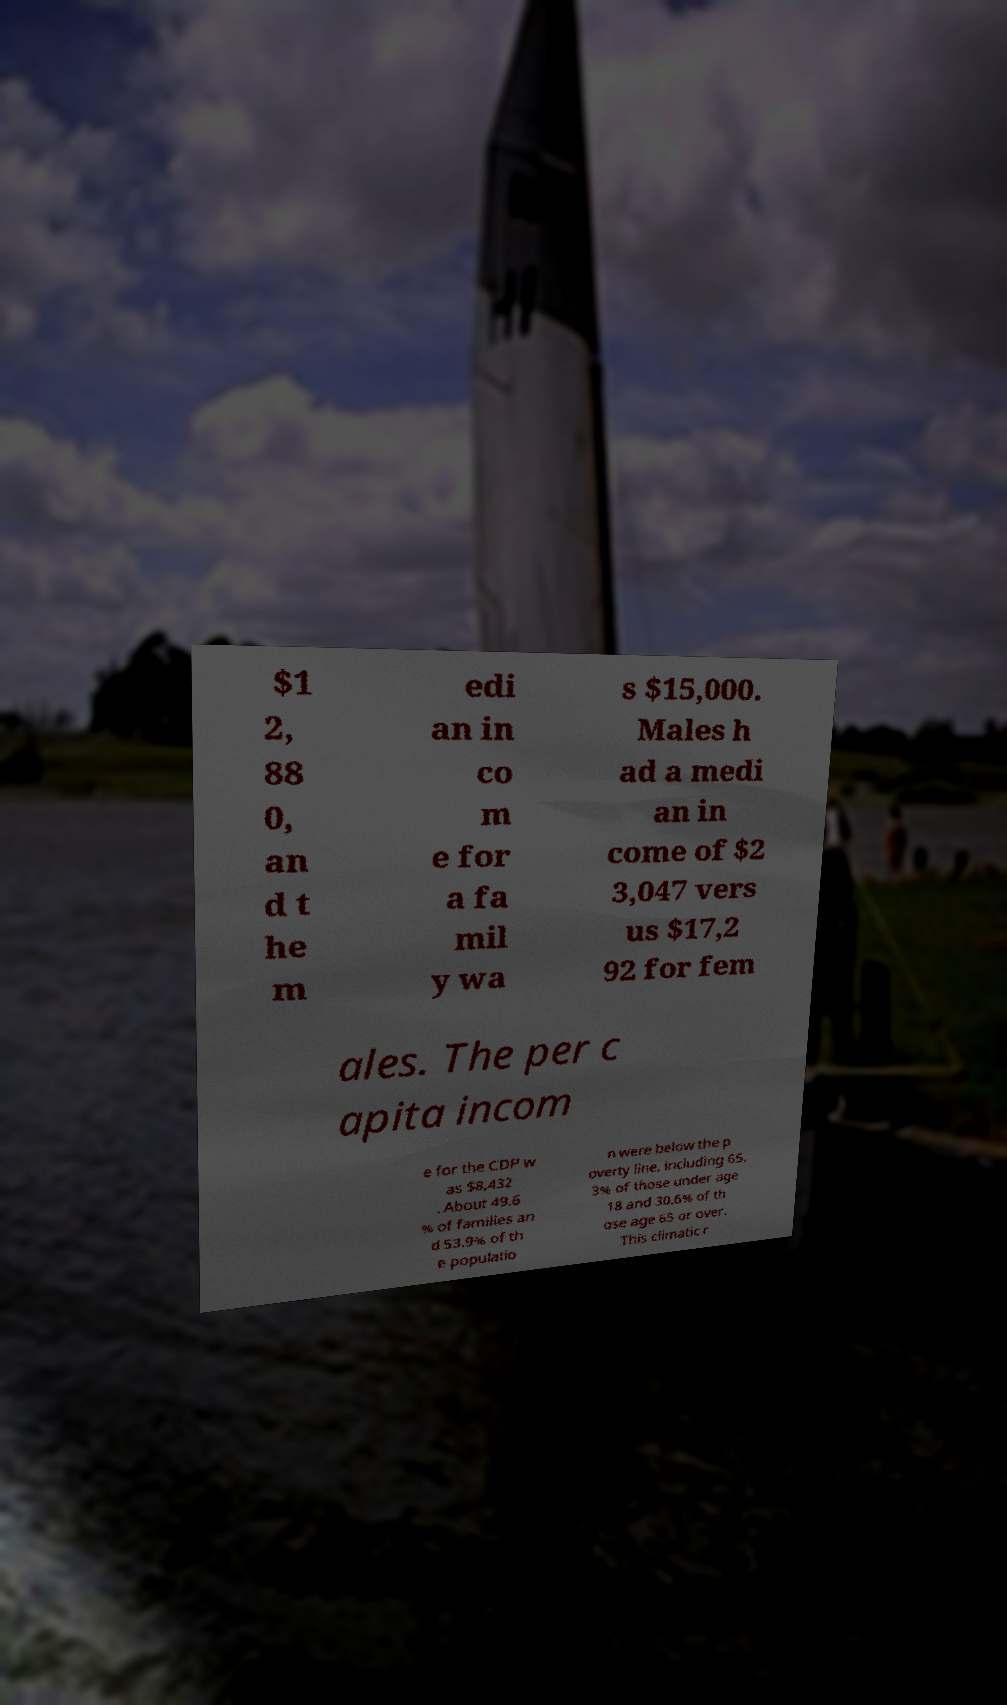Please identify and transcribe the text found in this image. $1 2, 88 0, an d t he m edi an in co m e for a fa mil y wa s $15,000. Males h ad a medi an in come of $2 3,047 vers us $17,2 92 for fem ales. The per c apita incom e for the CDP w as $8,432 . About 49.6 % of families an d 53.9% of th e populatio n were below the p overty line, including 65. 3% of those under age 18 and 30.6% of th ose age 65 or over. This climatic r 